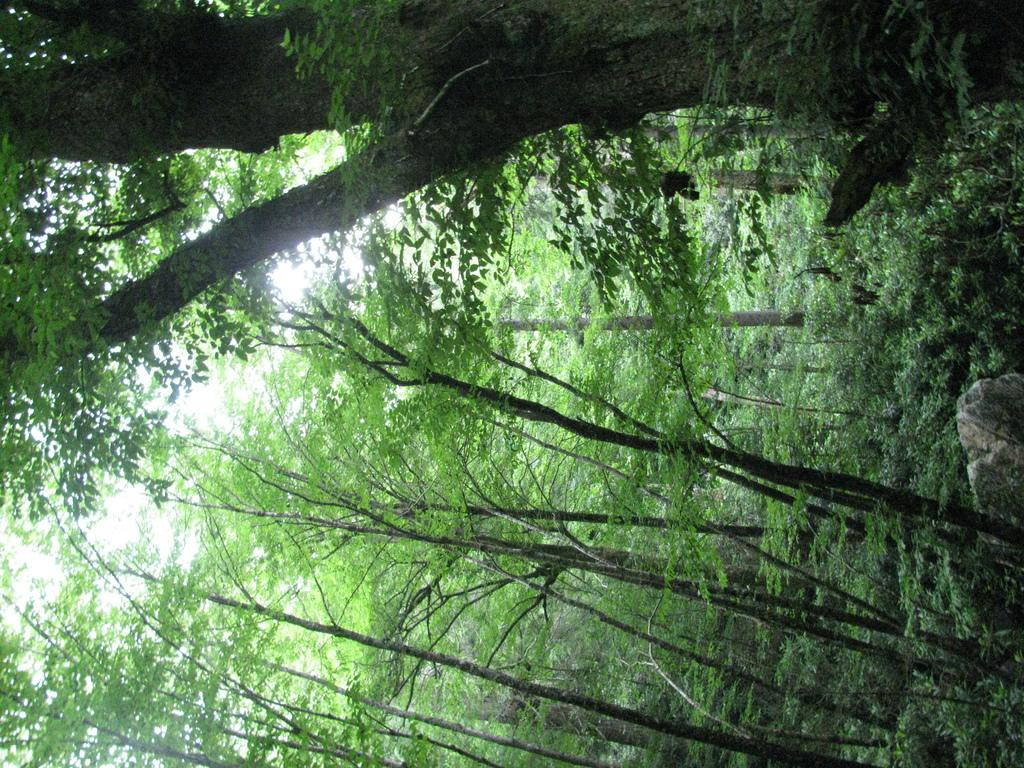What type of vegetation can be seen in the image? There are trees and plants in the image. Can you describe the trees in the image? The facts provided do not give specific details about the trees, but we can confirm that trees are present. What other type of vegetation is in the image besides trees? There are plants in the image. Where is the gun hidden in the image? There is no gun present in the image. What type of road can be seen in the image? There is no road present in the image; it features trees and plants. 